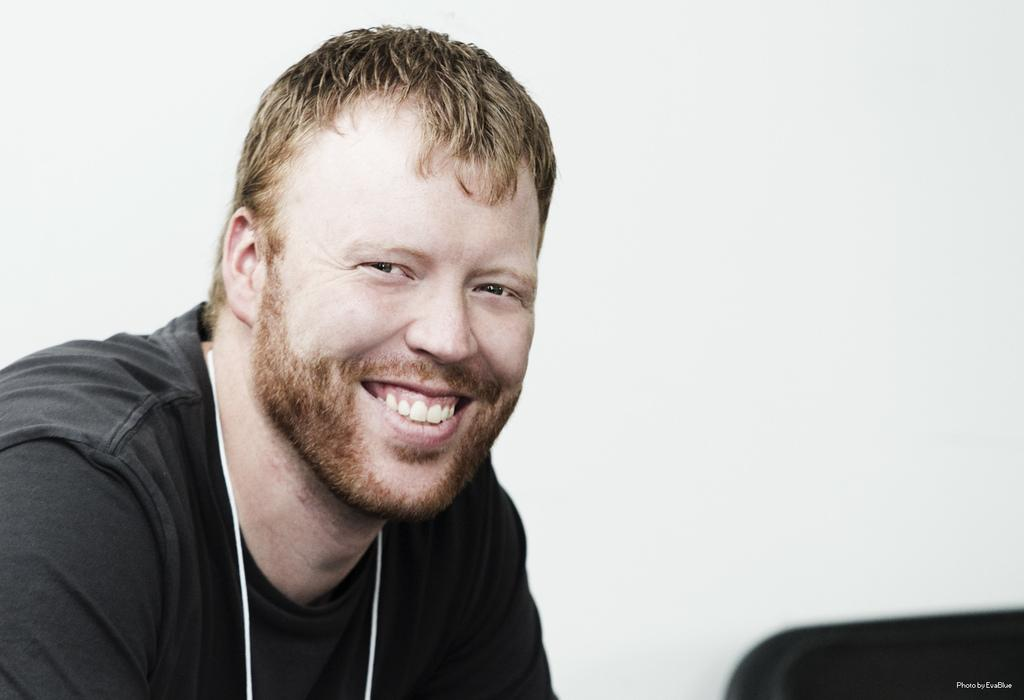Who is present in the image? There is a man in the image. What is the man's facial expression? The man is smiling. What color is the background of the image? The background of the image is white. What can be seen on the right side of the image? There is a black object on the right side of the image. What is associated with the black object? There is text associated with the black object. What degree does the judge hold in the image? There is no judge or degree mentioned in the image; it features a man smiling against a white background, with a black object and text on the right side. 